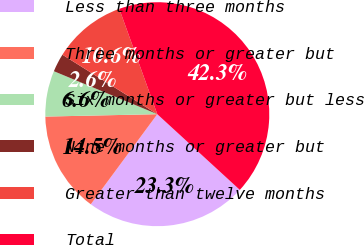<chart> <loc_0><loc_0><loc_500><loc_500><pie_chart><fcel>Less than three months<fcel>Three months or greater but<fcel>Six months or greater but less<fcel>Nine months or greater but<fcel>Greater than twelve months<fcel>Total<nl><fcel>23.31%<fcel>14.54%<fcel>6.61%<fcel>2.64%<fcel>10.58%<fcel>42.33%<nl></chart> 